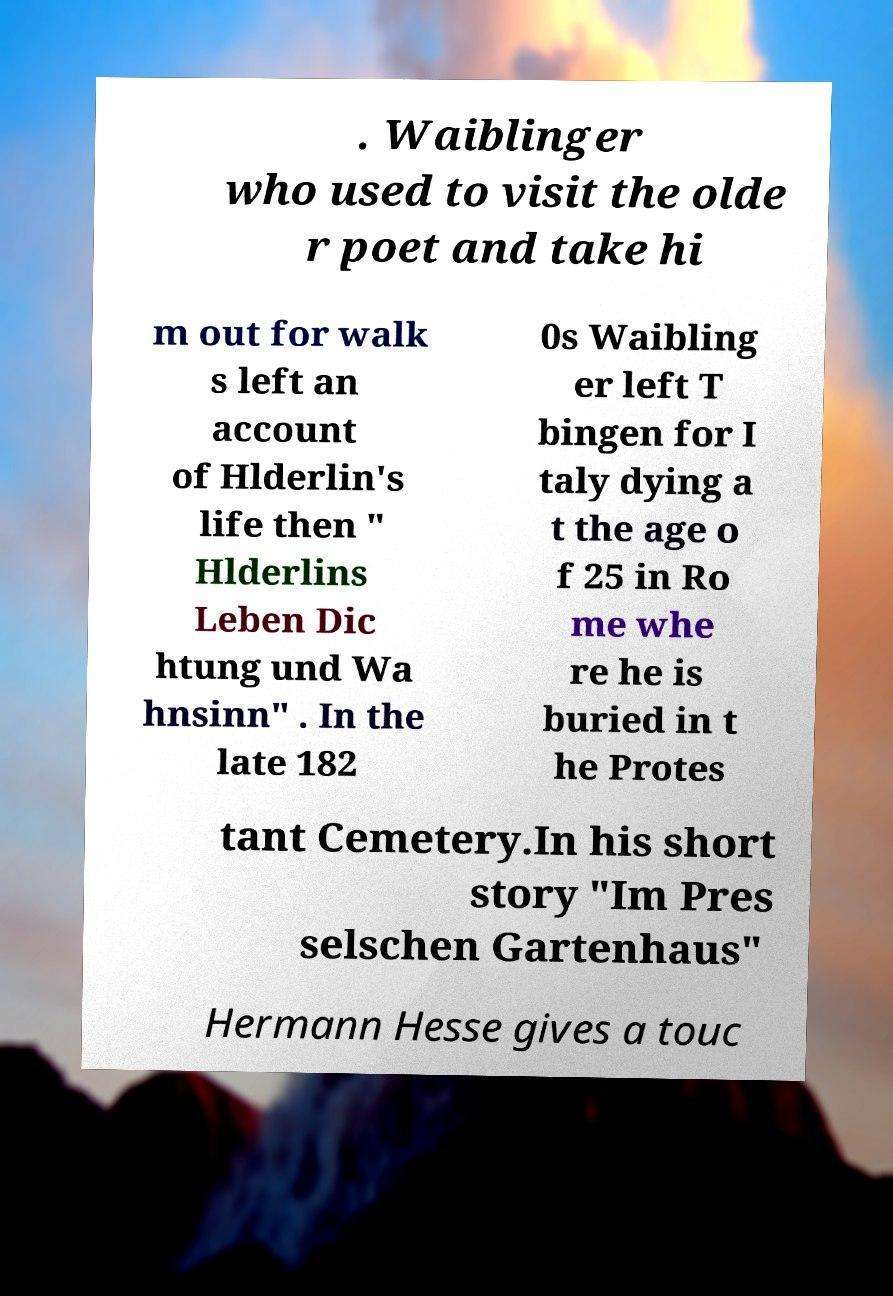Can you read and provide the text displayed in the image?This photo seems to have some interesting text. Can you extract and type it out for me? . Waiblinger who used to visit the olde r poet and take hi m out for walk s left an account of Hlderlin's life then " Hlderlins Leben Dic htung und Wa hnsinn" . In the late 182 0s Waibling er left T bingen for I taly dying a t the age o f 25 in Ro me whe re he is buried in t he Protes tant Cemetery.In his short story "Im Pres selschen Gartenhaus" Hermann Hesse gives a touc 